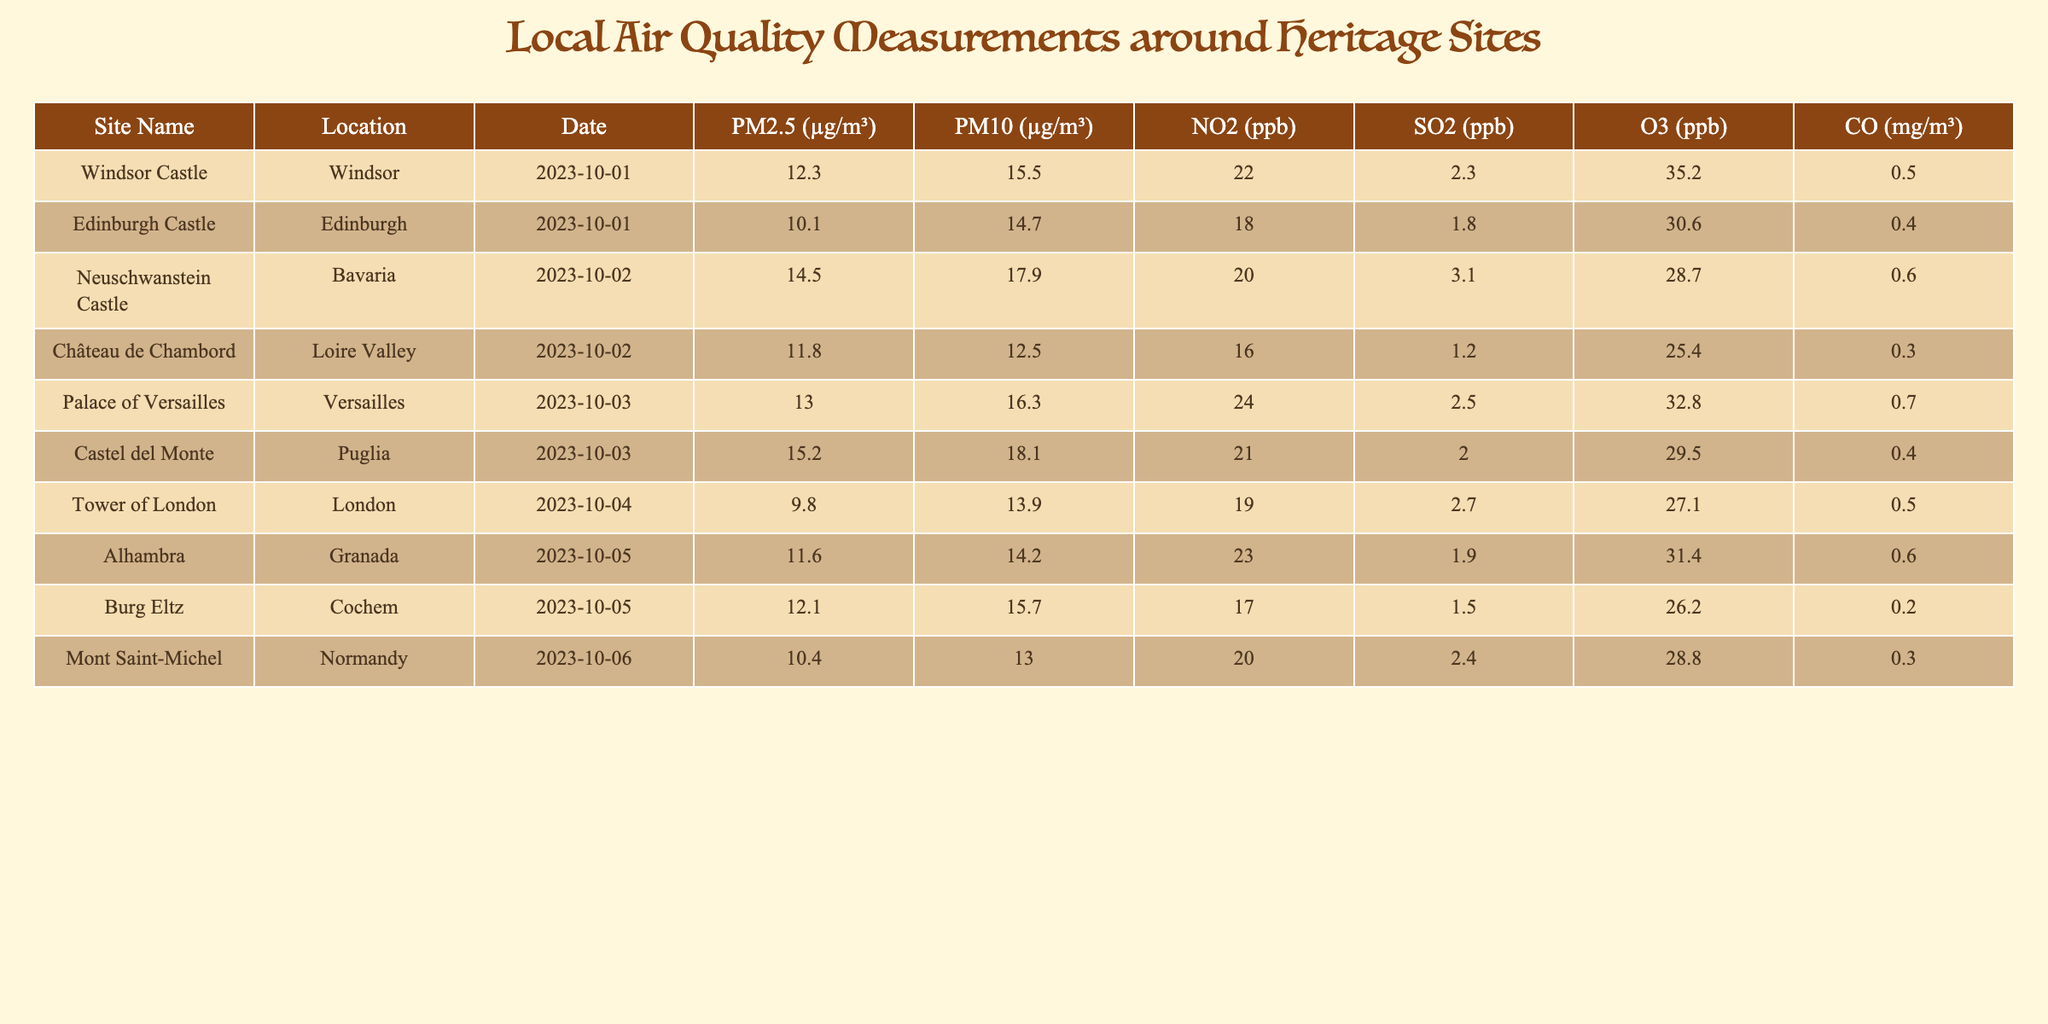What is the PM2.5 level recorded at Windsor Castle? The table shows a specific value for PM2.5 at Windsor Castle, which is listed under the corresponding column for that site. According to the data, the PM2.5 level is 12.3 µg/m³.
Answer: 12.3 µg/m³ Which site has the highest NO2 level? The NO2 values for each site can be compared to find the maximum. By examining the NO2 column, we see that the highest value is 24 ppb, which is recorded at the Palace of Versailles.
Answer: Palace of Versailles What is the difference in PM10 levels between Edinburgh Castle and Mont Saint-Michel? First, identify the PM10 levels: Edinburgh Castle has 14.7 µg/m³ and Mont Saint-Michel has 13.0 µg/m³. Now, calculate the difference: 14.7 - 13.0 = 1.7 µg/m³.
Answer: 1.7 µg/m³ Is the SO2 level at Alhambra greater than that at Château de Chambord? Check the SO2 values: Alhambra has 1.9 ppb and Château de Chambord has 1.2 ppb. Since 1.9 is greater than 1.2, the statement is true.
Answer: Yes What is the average level of O3 across all sites listed in the table? First, sum the O3 values: (35.2 + 30.6 + 28.7 + 25.4 + 32.8 + 29.5 + 27.1 + 31.4 + 26.2 + 28.8) =  295.7 ppb. There are 10 sites, so the average is 295.7 / 10 = 29.57 ppb.
Answer: 29.57 ppb Which site has the lowest PM2.5 concentration? By examining the PM2.5 column for all sites, the lowest value is found to be 9.8 µg/m³ at the Tower of London.
Answer: Tower of London What is the total CO level measured at the Château de Chambord and the Palace of Versailles? Identify the CO levels: Château de Chambord has 0.3 mg/m³ and the Palace of Versailles has 0.7 mg/m³. Summing these gives: 0.3 + 0.7 = 1.0 mg/m³.
Answer: 1.0 mg/m³ Are the PM10 levels at Castel del Monte and Burg Eltz equal? The PM10 levels for Castel del Monte and Burg Eltz are 18.1 µg/m³ and 15.7 µg/m³ respectively. Since these values differ, the answer is no.
Answer: No What would the total PM2.5 level be if we combined the values for Neuschwanstein Castle and Alhambra? The PM2.5 levels are 14.5 µg/m³ for Neuschwanstein Castle and 11.6 µg/m³ for Alhambra. Adding these gives: 14.5 + 11.6 = 26.1 µg/m³.
Answer: 26.1 µg/m³ 